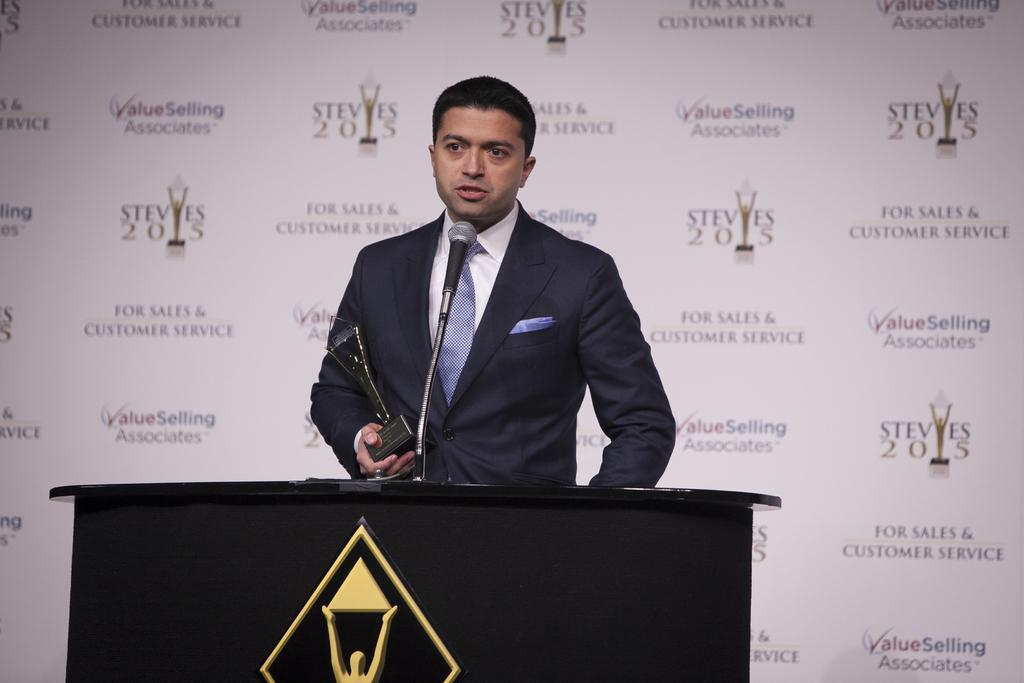Who is the main subject in the image? There is a man in the middle of the image. What is the man standing in front of? The man is standing in front of a podium. What is the man wearing? The man is wearing a coat. What is the man using to amplify his voice? There is a microphone (mic) in front of the man. What type of match is the man holding in the image? There is no match present in the image; the man is standing in front of a podium with a microphone. How does the wind affect the man's speech in the image? There is no wind present in the image, and therefore it cannot affect the man's speech. 